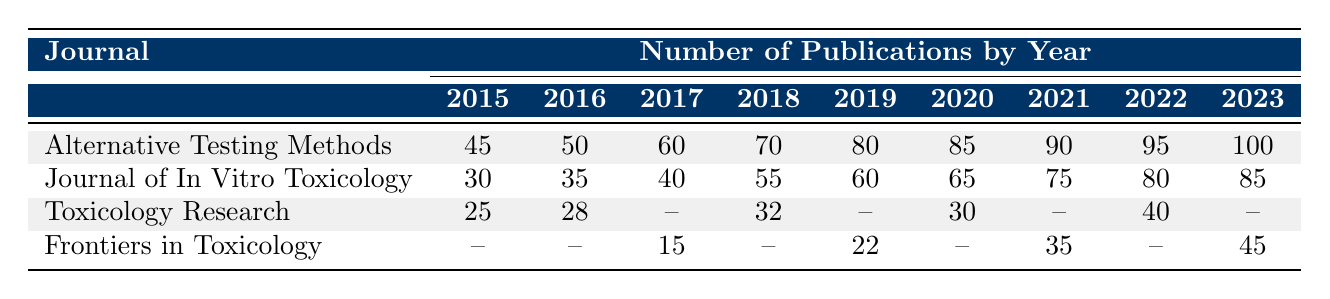What was the total number of publications in the "Alternative Testing Methods" journal in 2022? The table shows that the number of publications in the "Alternative Testing Methods" journal for the year 2022 is 95.
Answer: 95 Which journal had the highest number of publications in 2019? The table indicates that in 2019, "Alternative Testing Methods" had 80 publications, while "Journal of In Vitro Toxicology" had 60, and "Frontiers in Toxicology" had 22. Therefore, "Alternative Testing Methods" had the highest publications in that year.
Answer: Alternative Testing Methods What is the average number of publications for the "Journal of In Vitro Toxicology" from 2015 to 2023? The total number of publications for the "Journal of In Vitro Toxicology" from 2015 to 2023 is (30 + 35 + 40 + 55 + 60 + 65 + 75 + 80 + 85) = 485. There are 9 years, so the average is 485 / 9 ≈ 53.89.
Answer: Approximately 53.89 Did "Frontiers in Toxicology" publish any articles in 2016? Looking at the table, it shows that there are no publications listed for "Frontiers in Toxicology" in 2016, meaning it had 0 publications that year.
Answer: No How many total publications were made in the year 2021 across all journals shown in the table? The publications in 2021 for each journal are as follows: Alternative Testing Methods (90), Journal of In Vitro Toxicology (75), Toxicology Research (40), and Frontiers in Toxicology (35). Adding these gives: 90 + 75 + 40 + 35 = 240.
Answer: 240 In which year did "Toxicology Research" have the fewest publications and what was the number? From the table, "Toxicology Research" has only 25 publications in 2015, which is the lowest number across the years listed.
Answer: 2015, 25 What was the increase in the number of publications from 2020 to 2021 for the "Alternative Testing Methods" journal? The number of publications for "Alternative Testing Methods" in 2020 was 85, and in 2021 it was 90. The increase is 90 - 85 = 5.
Answer: 5 Which journal showed a consistent increase in the number of publications every year from 2015 to 2023? Examining the data, "Alternative Testing Methods" consistently increased from 45 in 2015 to 100 in 2023. The other journals did not show consistent increases due to some missing data points.
Answer: Alternative Testing Methods What was the total number of publications in 2023 across all journals? The number of publications in 2023 for each journal is: Alternative Testing Methods (100), Journal of In Vitro Toxicology (85), Toxicology Research (0), and Frontiers in Toxicology (45). Summing these gives: 100 + 85 + 0 + 45 = 230.
Answer: 230 Which year had the largest publication count in the "Journal of In Vitro Toxicology"? The table indicates that the highest publication count for the "Journal of In Vitro Toxicology" was 85 in both years 2022 and 2023.
Answer: 2022 and 2023, 85 